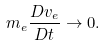Convert formula to latex. <formula><loc_0><loc_0><loc_500><loc_500>m _ { e } \frac { D v _ { e } } { D t } \rightarrow 0 .</formula> 